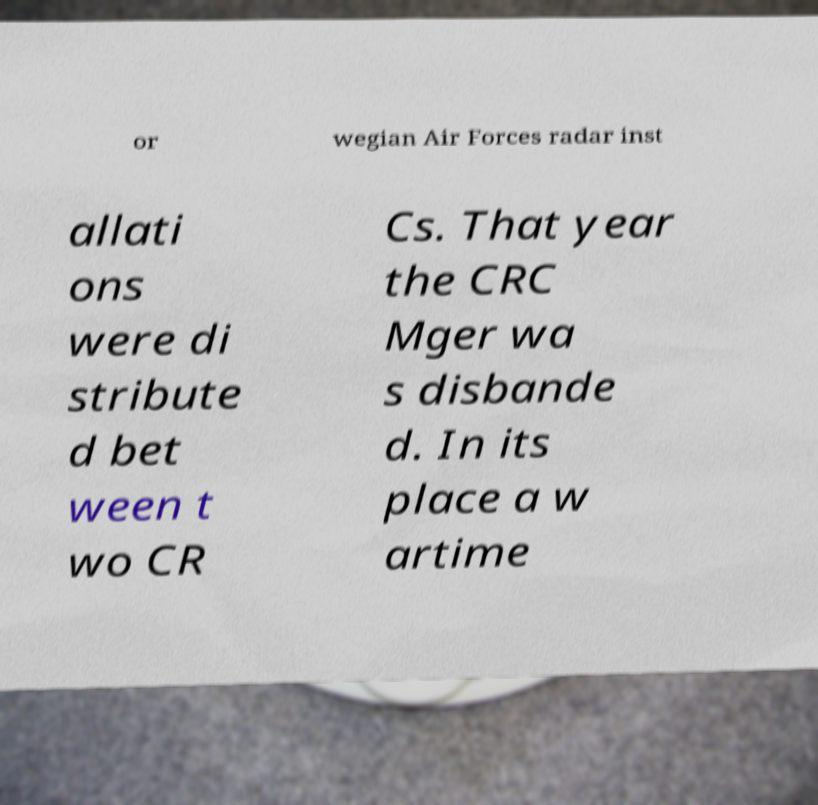There's text embedded in this image that I need extracted. Can you transcribe it verbatim? or wegian Air Forces radar inst allati ons were di stribute d bet ween t wo CR Cs. That year the CRC Mger wa s disbande d. In its place a w artime 